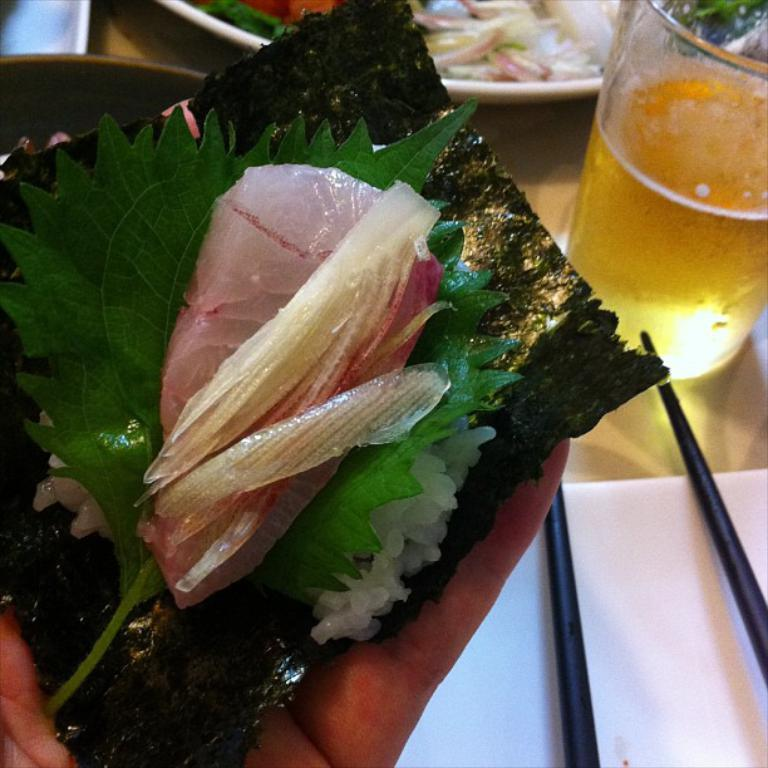What is the person in the image holding? The person is holding food in the image. Can you describe the color of the food? The food is white in color. What can be seen in the background of the image? There is a glass and other objects on the table in the background of the image. What type of card is the judge holding in the image? There is no card or judge present in the image. Can you see a monkey in the image? There is no monkey present in the image. 